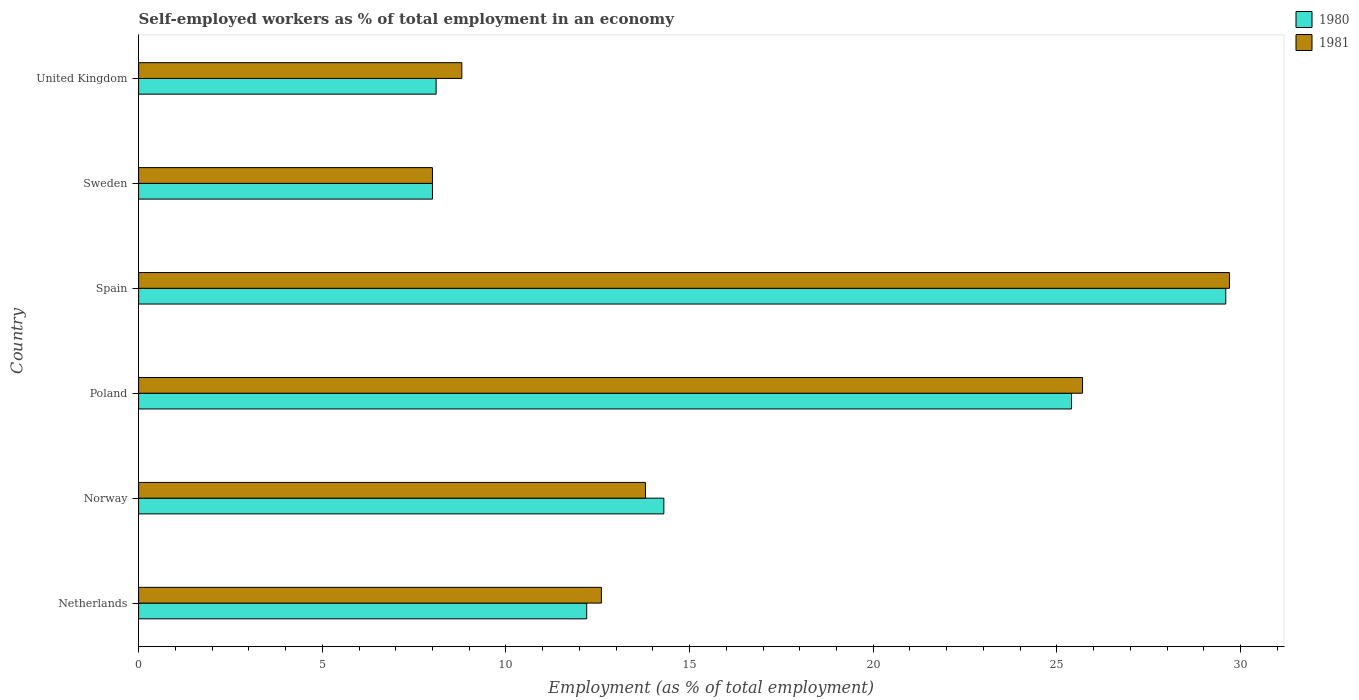How many different coloured bars are there?
Your answer should be very brief. 2. How many groups of bars are there?
Your answer should be very brief. 6. Are the number of bars on each tick of the Y-axis equal?
Make the answer very short. Yes. How many bars are there on the 1st tick from the bottom?
Offer a very short reply. 2. What is the percentage of self-employed workers in 1980 in Norway?
Provide a succinct answer. 14.3. Across all countries, what is the maximum percentage of self-employed workers in 1981?
Make the answer very short. 29.7. What is the total percentage of self-employed workers in 1981 in the graph?
Provide a short and direct response. 98.6. What is the difference between the percentage of self-employed workers in 1980 in Norway and that in Spain?
Provide a succinct answer. -15.3. What is the difference between the percentage of self-employed workers in 1980 in Norway and the percentage of self-employed workers in 1981 in Sweden?
Provide a succinct answer. 6.3. What is the average percentage of self-employed workers in 1981 per country?
Offer a terse response. 16.43. What is the difference between the percentage of self-employed workers in 1980 and percentage of self-employed workers in 1981 in Poland?
Your answer should be very brief. -0.3. In how many countries, is the percentage of self-employed workers in 1981 greater than 20 %?
Provide a succinct answer. 2. What is the ratio of the percentage of self-employed workers in 1980 in Netherlands to that in Sweden?
Offer a very short reply. 1.52. Is the percentage of self-employed workers in 1980 in Sweden less than that in United Kingdom?
Offer a terse response. Yes. Is the difference between the percentage of self-employed workers in 1980 in Poland and Spain greater than the difference between the percentage of self-employed workers in 1981 in Poland and Spain?
Your response must be concise. No. What is the difference between the highest and the lowest percentage of self-employed workers in 1981?
Keep it short and to the point. 21.7. Is the sum of the percentage of self-employed workers in 1981 in Norway and United Kingdom greater than the maximum percentage of self-employed workers in 1980 across all countries?
Offer a terse response. No. How many bars are there?
Your response must be concise. 12. How many countries are there in the graph?
Make the answer very short. 6. Are the values on the major ticks of X-axis written in scientific E-notation?
Your response must be concise. No. Does the graph contain any zero values?
Your response must be concise. No. Does the graph contain grids?
Offer a very short reply. No. How many legend labels are there?
Your response must be concise. 2. What is the title of the graph?
Make the answer very short. Self-employed workers as % of total employment in an economy. Does "2008" appear as one of the legend labels in the graph?
Give a very brief answer. No. What is the label or title of the X-axis?
Your answer should be compact. Employment (as % of total employment). What is the label or title of the Y-axis?
Give a very brief answer. Country. What is the Employment (as % of total employment) of 1980 in Netherlands?
Provide a succinct answer. 12.2. What is the Employment (as % of total employment) of 1981 in Netherlands?
Make the answer very short. 12.6. What is the Employment (as % of total employment) of 1980 in Norway?
Give a very brief answer. 14.3. What is the Employment (as % of total employment) of 1981 in Norway?
Your response must be concise. 13.8. What is the Employment (as % of total employment) in 1980 in Poland?
Ensure brevity in your answer.  25.4. What is the Employment (as % of total employment) of 1981 in Poland?
Make the answer very short. 25.7. What is the Employment (as % of total employment) of 1980 in Spain?
Provide a short and direct response. 29.6. What is the Employment (as % of total employment) in 1981 in Spain?
Make the answer very short. 29.7. What is the Employment (as % of total employment) in 1980 in Sweden?
Keep it short and to the point. 8. What is the Employment (as % of total employment) in 1980 in United Kingdom?
Give a very brief answer. 8.1. What is the Employment (as % of total employment) in 1981 in United Kingdom?
Offer a very short reply. 8.8. Across all countries, what is the maximum Employment (as % of total employment) in 1980?
Provide a short and direct response. 29.6. Across all countries, what is the maximum Employment (as % of total employment) of 1981?
Offer a terse response. 29.7. Across all countries, what is the minimum Employment (as % of total employment) of 1980?
Ensure brevity in your answer.  8. Across all countries, what is the minimum Employment (as % of total employment) of 1981?
Your response must be concise. 8. What is the total Employment (as % of total employment) of 1980 in the graph?
Offer a terse response. 97.6. What is the total Employment (as % of total employment) of 1981 in the graph?
Give a very brief answer. 98.6. What is the difference between the Employment (as % of total employment) in 1981 in Netherlands and that in Norway?
Ensure brevity in your answer.  -1.2. What is the difference between the Employment (as % of total employment) of 1980 in Netherlands and that in Spain?
Give a very brief answer. -17.4. What is the difference between the Employment (as % of total employment) of 1981 in Netherlands and that in Spain?
Provide a short and direct response. -17.1. What is the difference between the Employment (as % of total employment) in 1980 in Norway and that in Spain?
Your answer should be very brief. -15.3. What is the difference between the Employment (as % of total employment) in 1981 in Norway and that in Spain?
Make the answer very short. -15.9. What is the difference between the Employment (as % of total employment) in 1981 in Norway and that in United Kingdom?
Make the answer very short. 5. What is the difference between the Employment (as % of total employment) in 1980 in Poland and that in Spain?
Ensure brevity in your answer.  -4.2. What is the difference between the Employment (as % of total employment) in 1980 in Poland and that in Sweden?
Keep it short and to the point. 17.4. What is the difference between the Employment (as % of total employment) in 1980 in Spain and that in Sweden?
Give a very brief answer. 21.6. What is the difference between the Employment (as % of total employment) of 1981 in Spain and that in Sweden?
Ensure brevity in your answer.  21.7. What is the difference between the Employment (as % of total employment) in 1981 in Spain and that in United Kingdom?
Make the answer very short. 20.9. What is the difference between the Employment (as % of total employment) of 1980 in Sweden and that in United Kingdom?
Your answer should be very brief. -0.1. What is the difference between the Employment (as % of total employment) of 1981 in Sweden and that in United Kingdom?
Give a very brief answer. -0.8. What is the difference between the Employment (as % of total employment) in 1980 in Netherlands and the Employment (as % of total employment) in 1981 in Norway?
Your answer should be very brief. -1.6. What is the difference between the Employment (as % of total employment) in 1980 in Netherlands and the Employment (as % of total employment) in 1981 in Spain?
Provide a short and direct response. -17.5. What is the difference between the Employment (as % of total employment) in 1980 in Netherlands and the Employment (as % of total employment) in 1981 in Sweden?
Your answer should be very brief. 4.2. What is the difference between the Employment (as % of total employment) of 1980 in Norway and the Employment (as % of total employment) of 1981 in Spain?
Give a very brief answer. -15.4. What is the difference between the Employment (as % of total employment) in 1980 in Norway and the Employment (as % of total employment) in 1981 in United Kingdom?
Ensure brevity in your answer.  5.5. What is the difference between the Employment (as % of total employment) of 1980 in Poland and the Employment (as % of total employment) of 1981 in United Kingdom?
Offer a very short reply. 16.6. What is the difference between the Employment (as % of total employment) of 1980 in Spain and the Employment (as % of total employment) of 1981 in Sweden?
Offer a very short reply. 21.6. What is the difference between the Employment (as % of total employment) of 1980 in Spain and the Employment (as % of total employment) of 1981 in United Kingdom?
Give a very brief answer. 20.8. What is the difference between the Employment (as % of total employment) of 1980 in Sweden and the Employment (as % of total employment) of 1981 in United Kingdom?
Your answer should be compact. -0.8. What is the average Employment (as % of total employment) in 1980 per country?
Ensure brevity in your answer.  16.27. What is the average Employment (as % of total employment) of 1981 per country?
Give a very brief answer. 16.43. What is the difference between the Employment (as % of total employment) in 1980 and Employment (as % of total employment) in 1981 in Poland?
Your response must be concise. -0.3. What is the difference between the Employment (as % of total employment) in 1980 and Employment (as % of total employment) in 1981 in Sweden?
Ensure brevity in your answer.  0. What is the difference between the Employment (as % of total employment) of 1980 and Employment (as % of total employment) of 1981 in United Kingdom?
Give a very brief answer. -0.7. What is the ratio of the Employment (as % of total employment) of 1980 in Netherlands to that in Norway?
Provide a short and direct response. 0.85. What is the ratio of the Employment (as % of total employment) of 1980 in Netherlands to that in Poland?
Your answer should be very brief. 0.48. What is the ratio of the Employment (as % of total employment) in 1981 in Netherlands to that in Poland?
Give a very brief answer. 0.49. What is the ratio of the Employment (as % of total employment) in 1980 in Netherlands to that in Spain?
Give a very brief answer. 0.41. What is the ratio of the Employment (as % of total employment) of 1981 in Netherlands to that in Spain?
Your answer should be compact. 0.42. What is the ratio of the Employment (as % of total employment) in 1980 in Netherlands to that in Sweden?
Offer a terse response. 1.52. What is the ratio of the Employment (as % of total employment) in 1981 in Netherlands to that in Sweden?
Offer a very short reply. 1.57. What is the ratio of the Employment (as % of total employment) of 1980 in Netherlands to that in United Kingdom?
Offer a terse response. 1.51. What is the ratio of the Employment (as % of total employment) in 1981 in Netherlands to that in United Kingdom?
Offer a terse response. 1.43. What is the ratio of the Employment (as % of total employment) of 1980 in Norway to that in Poland?
Keep it short and to the point. 0.56. What is the ratio of the Employment (as % of total employment) of 1981 in Norway to that in Poland?
Give a very brief answer. 0.54. What is the ratio of the Employment (as % of total employment) of 1980 in Norway to that in Spain?
Give a very brief answer. 0.48. What is the ratio of the Employment (as % of total employment) in 1981 in Norway to that in Spain?
Keep it short and to the point. 0.46. What is the ratio of the Employment (as % of total employment) of 1980 in Norway to that in Sweden?
Give a very brief answer. 1.79. What is the ratio of the Employment (as % of total employment) of 1981 in Norway to that in Sweden?
Offer a terse response. 1.73. What is the ratio of the Employment (as % of total employment) of 1980 in Norway to that in United Kingdom?
Your answer should be very brief. 1.77. What is the ratio of the Employment (as % of total employment) of 1981 in Norway to that in United Kingdom?
Make the answer very short. 1.57. What is the ratio of the Employment (as % of total employment) in 1980 in Poland to that in Spain?
Your answer should be compact. 0.86. What is the ratio of the Employment (as % of total employment) of 1981 in Poland to that in Spain?
Your answer should be compact. 0.87. What is the ratio of the Employment (as % of total employment) of 1980 in Poland to that in Sweden?
Your answer should be very brief. 3.17. What is the ratio of the Employment (as % of total employment) of 1981 in Poland to that in Sweden?
Offer a very short reply. 3.21. What is the ratio of the Employment (as % of total employment) in 1980 in Poland to that in United Kingdom?
Ensure brevity in your answer.  3.14. What is the ratio of the Employment (as % of total employment) in 1981 in Poland to that in United Kingdom?
Your answer should be compact. 2.92. What is the ratio of the Employment (as % of total employment) of 1981 in Spain to that in Sweden?
Offer a very short reply. 3.71. What is the ratio of the Employment (as % of total employment) of 1980 in Spain to that in United Kingdom?
Your answer should be compact. 3.65. What is the ratio of the Employment (as % of total employment) of 1981 in Spain to that in United Kingdom?
Offer a terse response. 3.38. What is the difference between the highest and the lowest Employment (as % of total employment) in 1980?
Keep it short and to the point. 21.6. What is the difference between the highest and the lowest Employment (as % of total employment) of 1981?
Offer a terse response. 21.7. 